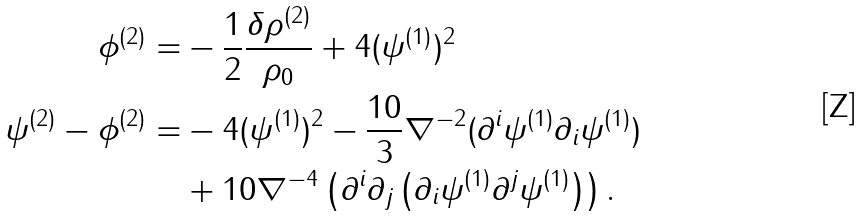<formula> <loc_0><loc_0><loc_500><loc_500>\phi ^ { ( 2 ) } = & - \frac { 1 } { 2 } \frac { \delta \rho ^ { ( 2 ) } } { \rho _ { 0 } } + 4 ( \psi ^ { ( 1 ) } ) ^ { 2 } \\ \psi ^ { ( 2 ) } - \phi ^ { ( 2 ) } = & - 4 ( \psi ^ { ( 1 ) } ) ^ { 2 } - \frac { 1 0 } { 3 } \nabla ^ { - 2 } ( \partial ^ { i } \psi ^ { ( 1 ) } \partial _ { i } \psi ^ { ( 1 ) } ) \\ & + 1 0 \nabla ^ { - 4 } \left ( \partial ^ { i } \partial _ { j } \left ( \partial _ { i } \psi ^ { ( 1 ) } \partial ^ { j } \psi ^ { ( 1 ) } \right ) \right ) . \\</formula> 